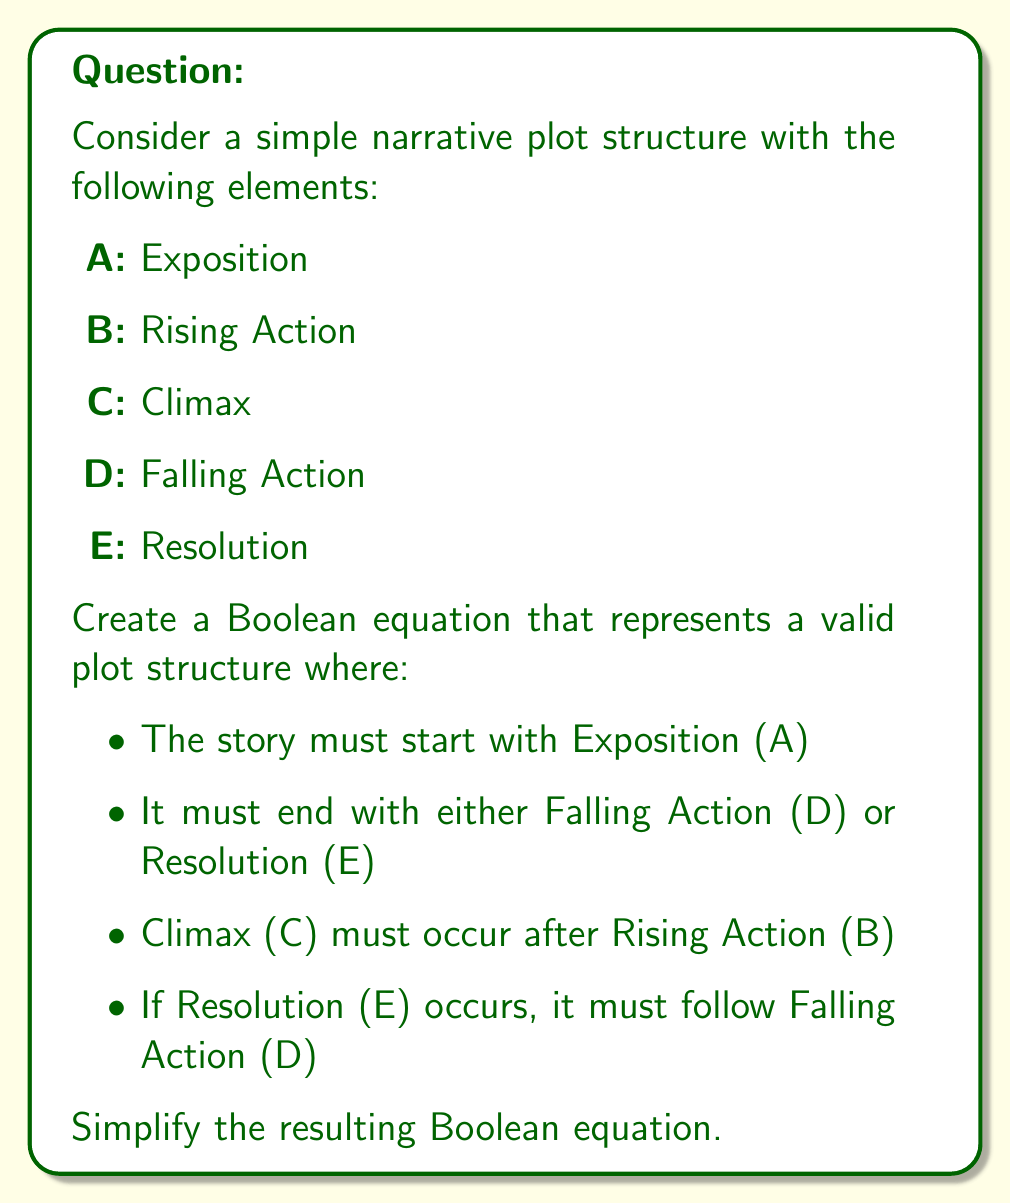Can you solve this math problem? Let's approach this step-by-step:

1) First, we'll create the Boolean equation based on the given conditions:

   $$(A) \cdot (B \cdot C) \cdot (D + (D \cdot E))$$

   This equation represents:
   - A must occur (Exposition)
   - B must occur before C (Rising Action before Climax)
   - The story ends with either D alone (Falling Action) or D followed by E (Falling Action then Resolution)

2) Let's simplify this equation:
   
   $$(A) \cdot (B \cdot C) \cdot (D + (D \cdot E))$$
   
   $= A \cdot B \cdot C \cdot (D + (D \cdot E))$$

3) We can factor out D from the last term:
   
   $$= A \cdot B \cdot C \cdot D \cdot (1 + E)$$

4) In Boolean algebra, $(1 + E) = 1$ for any E, so we can simplify further:

   $$= A \cdot B \cdot C \cdot D \cdot 1$$
   
   $$= A \cdot B \cdot C \cdot D$$

This final equation represents a valid plot structure that satisfies all the given conditions in the most simplified form.
Answer: $$A \cdot B \cdot C \cdot D$$ 